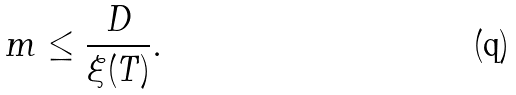<formula> <loc_0><loc_0><loc_500><loc_500>m \leq \frac { D } { \xi ( T ) } .</formula> 